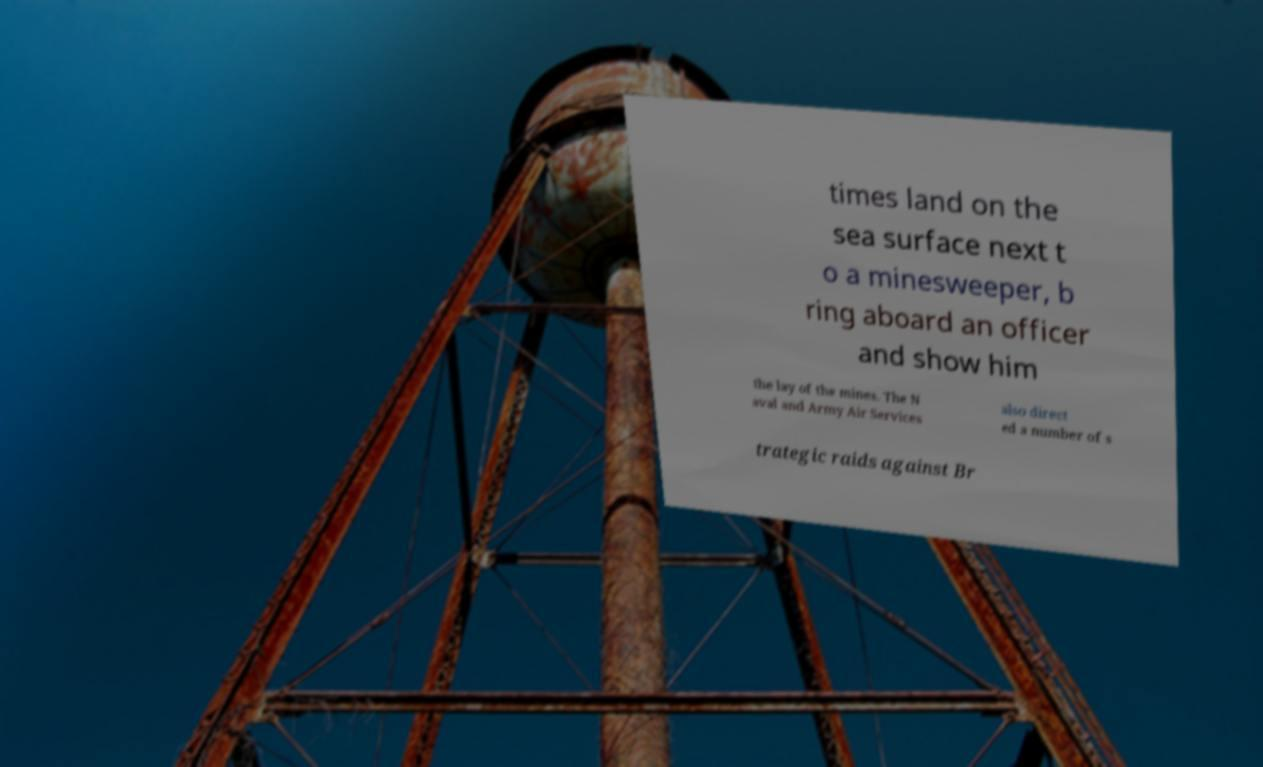Could you assist in decoding the text presented in this image and type it out clearly? times land on the sea surface next t o a minesweeper, b ring aboard an officer and show him the lay of the mines. The N aval and Army Air Services also direct ed a number of s trategic raids against Br 